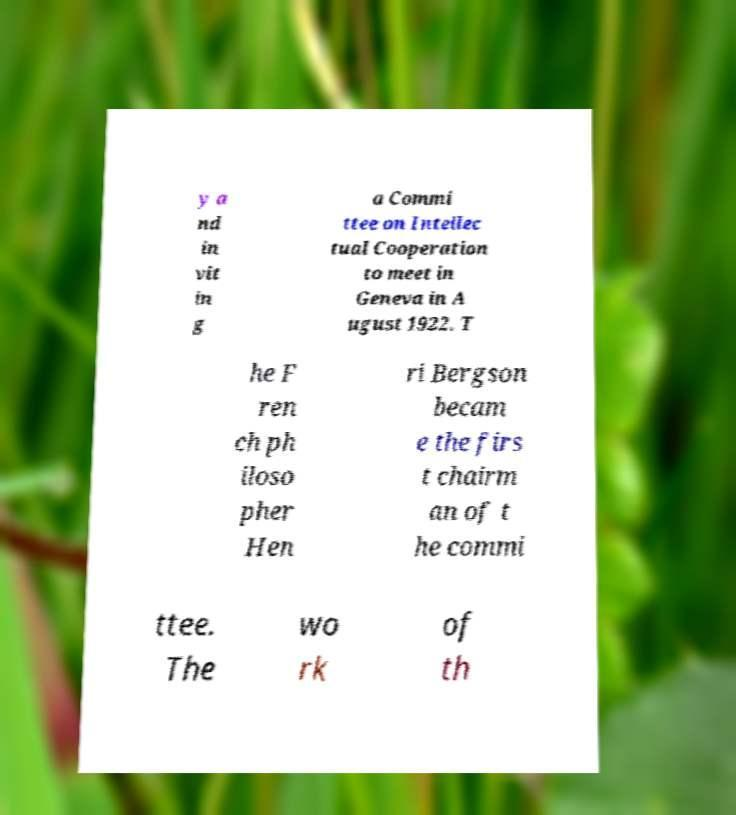Could you assist in decoding the text presented in this image and type it out clearly? y a nd in vit in g a Commi ttee on Intellec tual Cooperation to meet in Geneva in A ugust 1922. T he F ren ch ph iloso pher Hen ri Bergson becam e the firs t chairm an of t he commi ttee. The wo rk of th 